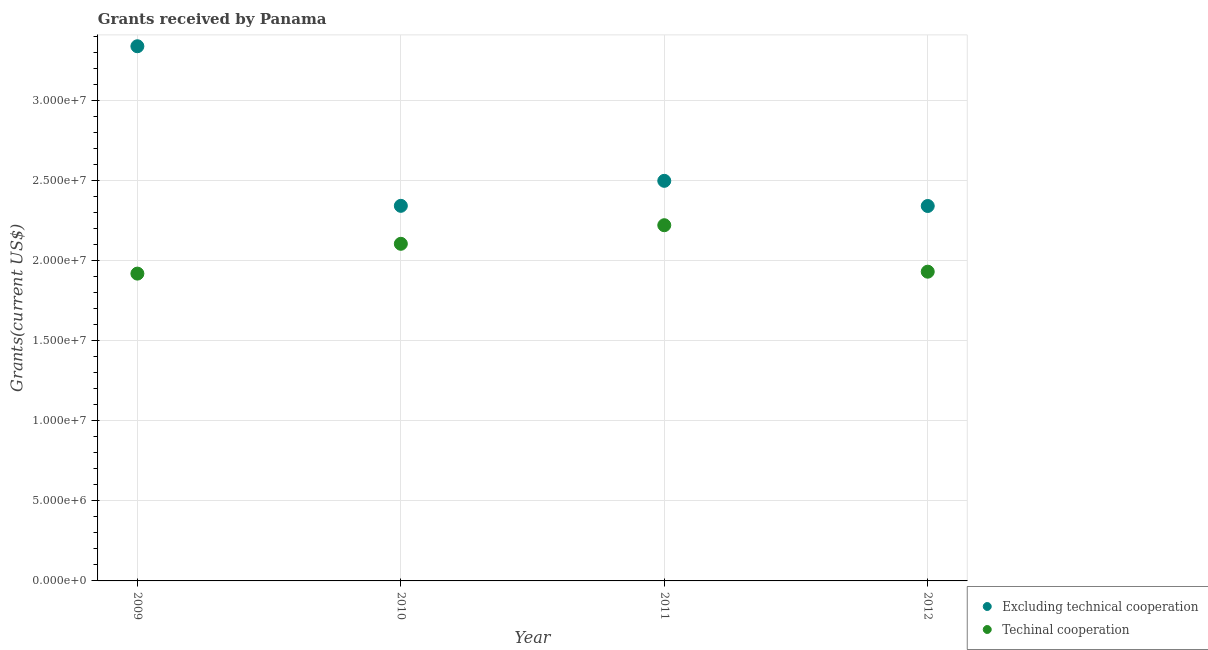How many different coloured dotlines are there?
Your response must be concise. 2. What is the amount of grants received(including technical cooperation) in 2010?
Ensure brevity in your answer.  2.10e+07. Across all years, what is the maximum amount of grants received(excluding technical cooperation)?
Your answer should be very brief. 3.34e+07. Across all years, what is the minimum amount of grants received(including technical cooperation)?
Keep it short and to the point. 1.92e+07. In which year was the amount of grants received(including technical cooperation) maximum?
Your response must be concise. 2011. In which year was the amount of grants received(excluding technical cooperation) minimum?
Your response must be concise. 2012. What is the total amount of grants received(including technical cooperation) in the graph?
Offer a terse response. 8.17e+07. What is the difference between the amount of grants received(excluding technical cooperation) in 2010 and that in 2011?
Provide a short and direct response. -1.56e+06. What is the difference between the amount of grants received(including technical cooperation) in 2012 and the amount of grants received(excluding technical cooperation) in 2009?
Your answer should be very brief. -1.41e+07. What is the average amount of grants received(excluding technical cooperation) per year?
Give a very brief answer. 2.63e+07. In the year 2010, what is the difference between the amount of grants received(including technical cooperation) and amount of grants received(excluding technical cooperation)?
Give a very brief answer. -2.37e+06. In how many years, is the amount of grants received(excluding technical cooperation) greater than 6000000 US$?
Offer a terse response. 4. What is the ratio of the amount of grants received(including technical cooperation) in 2010 to that in 2012?
Offer a very short reply. 1.09. Is the amount of grants received(excluding technical cooperation) in 2009 less than that in 2011?
Your response must be concise. No. What is the difference between the highest and the second highest amount of grants received(excluding technical cooperation)?
Offer a terse response. 8.40e+06. What is the difference between the highest and the lowest amount of grants received(including technical cooperation)?
Make the answer very short. 3.02e+06. In how many years, is the amount of grants received(excluding technical cooperation) greater than the average amount of grants received(excluding technical cooperation) taken over all years?
Provide a short and direct response. 1. Does the amount of grants received(excluding technical cooperation) monotonically increase over the years?
Ensure brevity in your answer.  No. How many dotlines are there?
Offer a very short reply. 2. What is the difference between two consecutive major ticks on the Y-axis?
Offer a very short reply. 5.00e+06. Does the graph contain any zero values?
Provide a short and direct response. No. Does the graph contain grids?
Make the answer very short. Yes. How many legend labels are there?
Offer a very short reply. 2. What is the title of the graph?
Give a very brief answer. Grants received by Panama. Does "Long-term debt" appear as one of the legend labels in the graph?
Your answer should be very brief. No. What is the label or title of the Y-axis?
Provide a succinct answer. Grants(current US$). What is the Grants(current US$) in Excluding technical cooperation in 2009?
Make the answer very short. 3.34e+07. What is the Grants(current US$) in Techinal cooperation in 2009?
Offer a very short reply. 1.92e+07. What is the Grants(current US$) in Excluding technical cooperation in 2010?
Keep it short and to the point. 2.34e+07. What is the Grants(current US$) in Techinal cooperation in 2010?
Provide a short and direct response. 2.10e+07. What is the Grants(current US$) in Excluding technical cooperation in 2011?
Ensure brevity in your answer.  2.50e+07. What is the Grants(current US$) of Techinal cooperation in 2011?
Make the answer very short. 2.22e+07. What is the Grants(current US$) of Excluding technical cooperation in 2012?
Give a very brief answer. 2.34e+07. What is the Grants(current US$) of Techinal cooperation in 2012?
Make the answer very short. 1.93e+07. Across all years, what is the maximum Grants(current US$) in Excluding technical cooperation?
Your answer should be compact. 3.34e+07. Across all years, what is the maximum Grants(current US$) in Techinal cooperation?
Your answer should be compact. 2.22e+07. Across all years, what is the minimum Grants(current US$) in Excluding technical cooperation?
Make the answer very short. 2.34e+07. Across all years, what is the minimum Grants(current US$) in Techinal cooperation?
Make the answer very short. 1.92e+07. What is the total Grants(current US$) of Excluding technical cooperation in the graph?
Provide a short and direct response. 1.05e+08. What is the total Grants(current US$) in Techinal cooperation in the graph?
Your answer should be compact. 8.17e+07. What is the difference between the Grants(current US$) of Excluding technical cooperation in 2009 and that in 2010?
Ensure brevity in your answer.  9.96e+06. What is the difference between the Grants(current US$) in Techinal cooperation in 2009 and that in 2010?
Provide a short and direct response. -1.86e+06. What is the difference between the Grants(current US$) of Excluding technical cooperation in 2009 and that in 2011?
Give a very brief answer. 8.40e+06. What is the difference between the Grants(current US$) in Techinal cooperation in 2009 and that in 2011?
Keep it short and to the point. -3.02e+06. What is the difference between the Grants(current US$) in Excluding technical cooperation in 2009 and that in 2012?
Keep it short and to the point. 9.97e+06. What is the difference between the Grants(current US$) in Techinal cooperation in 2009 and that in 2012?
Your response must be concise. -1.20e+05. What is the difference between the Grants(current US$) in Excluding technical cooperation in 2010 and that in 2011?
Make the answer very short. -1.56e+06. What is the difference between the Grants(current US$) of Techinal cooperation in 2010 and that in 2011?
Your response must be concise. -1.16e+06. What is the difference between the Grants(current US$) of Techinal cooperation in 2010 and that in 2012?
Provide a succinct answer. 1.74e+06. What is the difference between the Grants(current US$) in Excluding technical cooperation in 2011 and that in 2012?
Your response must be concise. 1.57e+06. What is the difference between the Grants(current US$) of Techinal cooperation in 2011 and that in 2012?
Give a very brief answer. 2.90e+06. What is the difference between the Grants(current US$) of Excluding technical cooperation in 2009 and the Grants(current US$) of Techinal cooperation in 2010?
Ensure brevity in your answer.  1.23e+07. What is the difference between the Grants(current US$) of Excluding technical cooperation in 2009 and the Grants(current US$) of Techinal cooperation in 2011?
Offer a terse response. 1.12e+07. What is the difference between the Grants(current US$) in Excluding technical cooperation in 2009 and the Grants(current US$) in Techinal cooperation in 2012?
Your answer should be very brief. 1.41e+07. What is the difference between the Grants(current US$) of Excluding technical cooperation in 2010 and the Grants(current US$) of Techinal cooperation in 2011?
Give a very brief answer. 1.21e+06. What is the difference between the Grants(current US$) of Excluding technical cooperation in 2010 and the Grants(current US$) of Techinal cooperation in 2012?
Ensure brevity in your answer.  4.11e+06. What is the difference between the Grants(current US$) in Excluding technical cooperation in 2011 and the Grants(current US$) in Techinal cooperation in 2012?
Ensure brevity in your answer.  5.67e+06. What is the average Grants(current US$) of Excluding technical cooperation per year?
Your answer should be compact. 2.63e+07. What is the average Grants(current US$) in Techinal cooperation per year?
Ensure brevity in your answer.  2.04e+07. In the year 2009, what is the difference between the Grants(current US$) in Excluding technical cooperation and Grants(current US$) in Techinal cooperation?
Give a very brief answer. 1.42e+07. In the year 2010, what is the difference between the Grants(current US$) in Excluding technical cooperation and Grants(current US$) in Techinal cooperation?
Give a very brief answer. 2.37e+06. In the year 2011, what is the difference between the Grants(current US$) in Excluding technical cooperation and Grants(current US$) in Techinal cooperation?
Provide a short and direct response. 2.77e+06. In the year 2012, what is the difference between the Grants(current US$) in Excluding technical cooperation and Grants(current US$) in Techinal cooperation?
Your response must be concise. 4.10e+06. What is the ratio of the Grants(current US$) in Excluding technical cooperation in 2009 to that in 2010?
Provide a succinct answer. 1.43. What is the ratio of the Grants(current US$) of Techinal cooperation in 2009 to that in 2010?
Make the answer very short. 0.91. What is the ratio of the Grants(current US$) of Excluding technical cooperation in 2009 to that in 2011?
Offer a terse response. 1.34. What is the ratio of the Grants(current US$) of Techinal cooperation in 2009 to that in 2011?
Keep it short and to the point. 0.86. What is the ratio of the Grants(current US$) of Excluding technical cooperation in 2009 to that in 2012?
Ensure brevity in your answer.  1.43. What is the ratio of the Grants(current US$) in Techinal cooperation in 2009 to that in 2012?
Ensure brevity in your answer.  0.99. What is the ratio of the Grants(current US$) in Techinal cooperation in 2010 to that in 2011?
Offer a terse response. 0.95. What is the ratio of the Grants(current US$) in Techinal cooperation in 2010 to that in 2012?
Offer a very short reply. 1.09. What is the ratio of the Grants(current US$) of Excluding technical cooperation in 2011 to that in 2012?
Make the answer very short. 1.07. What is the ratio of the Grants(current US$) in Techinal cooperation in 2011 to that in 2012?
Your answer should be compact. 1.15. What is the difference between the highest and the second highest Grants(current US$) of Excluding technical cooperation?
Ensure brevity in your answer.  8.40e+06. What is the difference between the highest and the second highest Grants(current US$) of Techinal cooperation?
Make the answer very short. 1.16e+06. What is the difference between the highest and the lowest Grants(current US$) in Excluding technical cooperation?
Offer a very short reply. 9.97e+06. What is the difference between the highest and the lowest Grants(current US$) in Techinal cooperation?
Keep it short and to the point. 3.02e+06. 